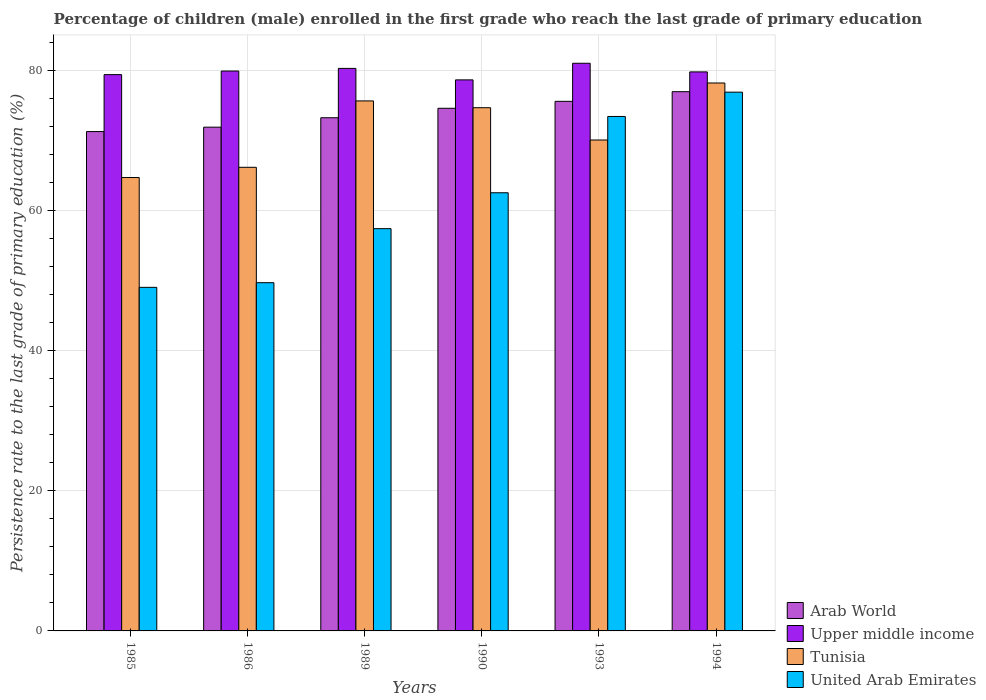How many different coloured bars are there?
Keep it short and to the point. 4. Are the number of bars per tick equal to the number of legend labels?
Make the answer very short. Yes. Are the number of bars on each tick of the X-axis equal?
Give a very brief answer. Yes. How many bars are there on the 5th tick from the left?
Keep it short and to the point. 4. How many bars are there on the 5th tick from the right?
Provide a short and direct response. 4. What is the label of the 4th group of bars from the left?
Ensure brevity in your answer.  1990. In how many cases, is the number of bars for a given year not equal to the number of legend labels?
Give a very brief answer. 0. What is the persistence rate of children in United Arab Emirates in 1994?
Provide a short and direct response. 76.92. Across all years, what is the maximum persistence rate of children in Upper middle income?
Offer a terse response. 81.05. Across all years, what is the minimum persistence rate of children in Arab World?
Your answer should be compact. 71.3. In which year was the persistence rate of children in Tunisia maximum?
Make the answer very short. 1994. In which year was the persistence rate of children in United Arab Emirates minimum?
Make the answer very short. 1985. What is the total persistence rate of children in United Arab Emirates in the graph?
Your answer should be compact. 369.13. What is the difference between the persistence rate of children in Upper middle income in 1993 and that in 1994?
Offer a very short reply. 1.23. What is the difference between the persistence rate of children in United Arab Emirates in 1989 and the persistence rate of children in Arab World in 1990?
Offer a terse response. -17.19. What is the average persistence rate of children in Tunisia per year?
Your answer should be compact. 71.6. In the year 1994, what is the difference between the persistence rate of children in Upper middle income and persistence rate of children in United Arab Emirates?
Your response must be concise. 2.89. What is the ratio of the persistence rate of children in United Arab Emirates in 1986 to that in 1989?
Provide a succinct answer. 0.87. What is the difference between the highest and the second highest persistence rate of children in Upper middle income?
Make the answer very short. 0.73. What is the difference between the highest and the lowest persistence rate of children in Upper middle income?
Offer a terse response. 2.37. In how many years, is the persistence rate of children in Upper middle income greater than the average persistence rate of children in Upper middle income taken over all years?
Ensure brevity in your answer.  3. What does the 4th bar from the left in 1989 represents?
Your response must be concise. United Arab Emirates. What does the 2nd bar from the right in 1993 represents?
Your response must be concise. Tunisia. Is it the case that in every year, the sum of the persistence rate of children in United Arab Emirates and persistence rate of children in Tunisia is greater than the persistence rate of children in Upper middle income?
Offer a very short reply. Yes. Are all the bars in the graph horizontal?
Make the answer very short. No. Does the graph contain grids?
Keep it short and to the point. Yes. Where does the legend appear in the graph?
Your answer should be very brief. Bottom right. How many legend labels are there?
Offer a very short reply. 4. What is the title of the graph?
Give a very brief answer. Percentage of children (male) enrolled in the first grade who reach the last grade of primary education. What is the label or title of the Y-axis?
Provide a succinct answer. Persistence rate to the last grade of primary education (%). What is the Persistence rate to the last grade of primary education (%) in Arab World in 1985?
Your answer should be very brief. 71.3. What is the Persistence rate to the last grade of primary education (%) in Upper middle income in 1985?
Make the answer very short. 79.43. What is the Persistence rate to the last grade of primary education (%) in Tunisia in 1985?
Provide a short and direct response. 64.73. What is the Persistence rate to the last grade of primary education (%) in United Arab Emirates in 1985?
Offer a very short reply. 49.05. What is the Persistence rate to the last grade of primary education (%) in Arab World in 1986?
Your answer should be compact. 71.92. What is the Persistence rate to the last grade of primary education (%) of Upper middle income in 1986?
Provide a succinct answer. 79.94. What is the Persistence rate to the last grade of primary education (%) of Tunisia in 1986?
Provide a short and direct response. 66.19. What is the Persistence rate to the last grade of primary education (%) in United Arab Emirates in 1986?
Give a very brief answer. 49.72. What is the Persistence rate to the last grade of primary education (%) in Arab World in 1989?
Provide a short and direct response. 73.27. What is the Persistence rate to the last grade of primary education (%) in Upper middle income in 1989?
Provide a short and direct response. 80.31. What is the Persistence rate to the last grade of primary education (%) in Tunisia in 1989?
Make the answer very short. 75.67. What is the Persistence rate to the last grade of primary education (%) of United Arab Emirates in 1989?
Offer a terse response. 57.43. What is the Persistence rate to the last grade of primary education (%) of Arab World in 1990?
Your answer should be very brief. 74.62. What is the Persistence rate to the last grade of primary education (%) of Upper middle income in 1990?
Provide a succinct answer. 78.67. What is the Persistence rate to the last grade of primary education (%) of Tunisia in 1990?
Provide a succinct answer. 74.7. What is the Persistence rate to the last grade of primary education (%) in United Arab Emirates in 1990?
Provide a succinct answer. 62.56. What is the Persistence rate to the last grade of primary education (%) in Arab World in 1993?
Make the answer very short. 75.61. What is the Persistence rate to the last grade of primary education (%) of Upper middle income in 1993?
Your answer should be compact. 81.05. What is the Persistence rate to the last grade of primary education (%) in Tunisia in 1993?
Keep it short and to the point. 70.09. What is the Persistence rate to the last grade of primary education (%) in United Arab Emirates in 1993?
Your answer should be compact. 73.45. What is the Persistence rate to the last grade of primary education (%) of Arab World in 1994?
Give a very brief answer. 76.99. What is the Persistence rate to the last grade of primary education (%) in Upper middle income in 1994?
Your answer should be very brief. 79.81. What is the Persistence rate to the last grade of primary education (%) of Tunisia in 1994?
Your answer should be very brief. 78.23. What is the Persistence rate to the last grade of primary education (%) in United Arab Emirates in 1994?
Your response must be concise. 76.92. Across all years, what is the maximum Persistence rate to the last grade of primary education (%) of Arab World?
Ensure brevity in your answer.  76.99. Across all years, what is the maximum Persistence rate to the last grade of primary education (%) in Upper middle income?
Make the answer very short. 81.05. Across all years, what is the maximum Persistence rate to the last grade of primary education (%) of Tunisia?
Keep it short and to the point. 78.23. Across all years, what is the maximum Persistence rate to the last grade of primary education (%) in United Arab Emirates?
Your answer should be very brief. 76.92. Across all years, what is the minimum Persistence rate to the last grade of primary education (%) of Arab World?
Provide a succinct answer. 71.3. Across all years, what is the minimum Persistence rate to the last grade of primary education (%) in Upper middle income?
Offer a terse response. 78.67. Across all years, what is the minimum Persistence rate to the last grade of primary education (%) of Tunisia?
Ensure brevity in your answer.  64.73. Across all years, what is the minimum Persistence rate to the last grade of primary education (%) in United Arab Emirates?
Offer a very short reply. 49.05. What is the total Persistence rate to the last grade of primary education (%) in Arab World in the graph?
Your answer should be very brief. 443.71. What is the total Persistence rate to the last grade of primary education (%) in Upper middle income in the graph?
Keep it short and to the point. 479.21. What is the total Persistence rate to the last grade of primary education (%) in Tunisia in the graph?
Make the answer very short. 429.62. What is the total Persistence rate to the last grade of primary education (%) in United Arab Emirates in the graph?
Provide a succinct answer. 369.13. What is the difference between the Persistence rate to the last grade of primary education (%) in Arab World in 1985 and that in 1986?
Ensure brevity in your answer.  -0.63. What is the difference between the Persistence rate to the last grade of primary education (%) in Upper middle income in 1985 and that in 1986?
Your response must be concise. -0.51. What is the difference between the Persistence rate to the last grade of primary education (%) of Tunisia in 1985 and that in 1986?
Offer a very short reply. -1.46. What is the difference between the Persistence rate to the last grade of primary education (%) of United Arab Emirates in 1985 and that in 1986?
Your response must be concise. -0.66. What is the difference between the Persistence rate to the last grade of primary education (%) in Arab World in 1985 and that in 1989?
Offer a terse response. -1.97. What is the difference between the Persistence rate to the last grade of primary education (%) of Upper middle income in 1985 and that in 1989?
Make the answer very short. -0.89. What is the difference between the Persistence rate to the last grade of primary education (%) of Tunisia in 1985 and that in 1989?
Offer a terse response. -10.94. What is the difference between the Persistence rate to the last grade of primary education (%) of United Arab Emirates in 1985 and that in 1989?
Ensure brevity in your answer.  -8.38. What is the difference between the Persistence rate to the last grade of primary education (%) of Arab World in 1985 and that in 1990?
Provide a succinct answer. -3.32. What is the difference between the Persistence rate to the last grade of primary education (%) of Upper middle income in 1985 and that in 1990?
Keep it short and to the point. 0.75. What is the difference between the Persistence rate to the last grade of primary education (%) in Tunisia in 1985 and that in 1990?
Ensure brevity in your answer.  -9.97. What is the difference between the Persistence rate to the last grade of primary education (%) of United Arab Emirates in 1985 and that in 1990?
Your response must be concise. -13.5. What is the difference between the Persistence rate to the last grade of primary education (%) in Arab World in 1985 and that in 1993?
Offer a very short reply. -4.32. What is the difference between the Persistence rate to the last grade of primary education (%) in Upper middle income in 1985 and that in 1993?
Ensure brevity in your answer.  -1.62. What is the difference between the Persistence rate to the last grade of primary education (%) of Tunisia in 1985 and that in 1993?
Your response must be concise. -5.36. What is the difference between the Persistence rate to the last grade of primary education (%) in United Arab Emirates in 1985 and that in 1993?
Provide a succinct answer. -24.4. What is the difference between the Persistence rate to the last grade of primary education (%) in Arab World in 1985 and that in 1994?
Provide a short and direct response. -5.69. What is the difference between the Persistence rate to the last grade of primary education (%) in Upper middle income in 1985 and that in 1994?
Ensure brevity in your answer.  -0.39. What is the difference between the Persistence rate to the last grade of primary education (%) of Tunisia in 1985 and that in 1994?
Your answer should be compact. -13.5. What is the difference between the Persistence rate to the last grade of primary education (%) in United Arab Emirates in 1985 and that in 1994?
Your response must be concise. -27.87. What is the difference between the Persistence rate to the last grade of primary education (%) in Arab World in 1986 and that in 1989?
Offer a very short reply. -1.35. What is the difference between the Persistence rate to the last grade of primary education (%) of Upper middle income in 1986 and that in 1989?
Make the answer very short. -0.37. What is the difference between the Persistence rate to the last grade of primary education (%) of Tunisia in 1986 and that in 1989?
Your answer should be very brief. -9.48. What is the difference between the Persistence rate to the last grade of primary education (%) of United Arab Emirates in 1986 and that in 1989?
Provide a short and direct response. -7.71. What is the difference between the Persistence rate to the last grade of primary education (%) of Arab World in 1986 and that in 1990?
Offer a very short reply. -2.7. What is the difference between the Persistence rate to the last grade of primary education (%) in Upper middle income in 1986 and that in 1990?
Provide a short and direct response. 1.27. What is the difference between the Persistence rate to the last grade of primary education (%) in Tunisia in 1986 and that in 1990?
Provide a short and direct response. -8.51. What is the difference between the Persistence rate to the last grade of primary education (%) of United Arab Emirates in 1986 and that in 1990?
Your answer should be very brief. -12.84. What is the difference between the Persistence rate to the last grade of primary education (%) of Arab World in 1986 and that in 1993?
Your answer should be very brief. -3.69. What is the difference between the Persistence rate to the last grade of primary education (%) of Upper middle income in 1986 and that in 1993?
Offer a terse response. -1.11. What is the difference between the Persistence rate to the last grade of primary education (%) in Tunisia in 1986 and that in 1993?
Your response must be concise. -3.9. What is the difference between the Persistence rate to the last grade of primary education (%) in United Arab Emirates in 1986 and that in 1993?
Make the answer very short. -23.73. What is the difference between the Persistence rate to the last grade of primary education (%) of Arab World in 1986 and that in 1994?
Keep it short and to the point. -5.07. What is the difference between the Persistence rate to the last grade of primary education (%) in Upper middle income in 1986 and that in 1994?
Offer a very short reply. 0.13. What is the difference between the Persistence rate to the last grade of primary education (%) in Tunisia in 1986 and that in 1994?
Ensure brevity in your answer.  -12.04. What is the difference between the Persistence rate to the last grade of primary education (%) of United Arab Emirates in 1986 and that in 1994?
Give a very brief answer. -27.2. What is the difference between the Persistence rate to the last grade of primary education (%) of Arab World in 1989 and that in 1990?
Provide a short and direct response. -1.35. What is the difference between the Persistence rate to the last grade of primary education (%) in Upper middle income in 1989 and that in 1990?
Provide a succinct answer. 1.64. What is the difference between the Persistence rate to the last grade of primary education (%) of Tunisia in 1989 and that in 1990?
Your answer should be very brief. 0.97. What is the difference between the Persistence rate to the last grade of primary education (%) in United Arab Emirates in 1989 and that in 1990?
Your response must be concise. -5.13. What is the difference between the Persistence rate to the last grade of primary education (%) in Arab World in 1989 and that in 1993?
Keep it short and to the point. -2.34. What is the difference between the Persistence rate to the last grade of primary education (%) of Upper middle income in 1989 and that in 1993?
Ensure brevity in your answer.  -0.73. What is the difference between the Persistence rate to the last grade of primary education (%) in Tunisia in 1989 and that in 1993?
Make the answer very short. 5.58. What is the difference between the Persistence rate to the last grade of primary education (%) in United Arab Emirates in 1989 and that in 1993?
Provide a succinct answer. -16.02. What is the difference between the Persistence rate to the last grade of primary education (%) in Arab World in 1989 and that in 1994?
Keep it short and to the point. -3.72. What is the difference between the Persistence rate to the last grade of primary education (%) in Upper middle income in 1989 and that in 1994?
Your response must be concise. 0.5. What is the difference between the Persistence rate to the last grade of primary education (%) in Tunisia in 1989 and that in 1994?
Make the answer very short. -2.56. What is the difference between the Persistence rate to the last grade of primary education (%) in United Arab Emirates in 1989 and that in 1994?
Offer a very short reply. -19.49. What is the difference between the Persistence rate to the last grade of primary education (%) in Arab World in 1990 and that in 1993?
Provide a succinct answer. -0.99. What is the difference between the Persistence rate to the last grade of primary education (%) in Upper middle income in 1990 and that in 1993?
Your response must be concise. -2.37. What is the difference between the Persistence rate to the last grade of primary education (%) in Tunisia in 1990 and that in 1993?
Give a very brief answer. 4.61. What is the difference between the Persistence rate to the last grade of primary education (%) of United Arab Emirates in 1990 and that in 1993?
Your response must be concise. -10.89. What is the difference between the Persistence rate to the last grade of primary education (%) in Arab World in 1990 and that in 1994?
Offer a very short reply. -2.37. What is the difference between the Persistence rate to the last grade of primary education (%) of Upper middle income in 1990 and that in 1994?
Keep it short and to the point. -1.14. What is the difference between the Persistence rate to the last grade of primary education (%) in Tunisia in 1990 and that in 1994?
Provide a succinct answer. -3.53. What is the difference between the Persistence rate to the last grade of primary education (%) of United Arab Emirates in 1990 and that in 1994?
Ensure brevity in your answer.  -14.36. What is the difference between the Persistence rate to the last grade of primary education (%) in Arab World in 1993 and that in 1994?
Make the answer very short. -1.38. What is the difference between the Persistence rate to the last grade of primary education (%) in Upper middle income in 1993 and that in 1994?
Provide a succinct answer. 1.23. What is the difference between the Persistence rate to the last grade of primary education (%) in Tunisia in 1993 and that in 1994?
Offer a very short reply. -8.14. What is the difference between the Persistence rate to the last grade of primary education (%) of United Arab Emirates in 1993 and that in 1994?
Offer a very short reply. -3.47. What is the difference between the Persistence rate to the last grade of primary education (%) in Arab World in 1985 and the Persistence rate to the last grade of primary education (%) in Upper middle income in 1986?
Provide a short and direct response. -8.64. What is the difference between the Persistence rate to the last grade of primary education (%) in Arab World in 1985 and the Persistence rate to the last grade of primary education (%) in Tunisia in 1986?
Your response must be concise. 5.1. What is the difference between the Persistence rate to the last grade of primary education (%) in Arab World in 1985 and the Persistence rate to the last grade of primary education (%) in United Arab Emirates in 1986?
Offer a terse response. 21.58. What is the difference between the Persistence rate to the last grade of primary education (%) of Upper middle income in 1985 and the Persistence rate to the last grade of primary education (%) of Tunisia in 1986?
Give a very brief answer. 13.23. What is the difference between the Persistence rate to the last grade of primary education (%) in Upper middle income in 1985 and the Persistence rate to the last grade of primary education (%) in United Arab Emirates in 1986?
Provide a succinct answer. 29.71. What is the difference between the Persistence rate to the last grade of primary education (%) in Tunisia in 1985 and the Persistence rate to the last grade of primary education (%) in United Arab Emirates in 1986?
Ensure brevity in your answer.  15.01. What is the difference between the Persistence rate to the last grade of primary education (%) of Arab World in 1985 and the Persistence rate to the last grade of primary education (%) of Upper middle income in 1989?
Keep it short and to the point. -9.02. What is the difference between the Persistence rate to the last grade of primary education (%) of Arab World in 1985 and the Persistence rate to the last grade of primary education (%) of Tunisia in 1989?
Keep it short and to the point. -4.38. What is the difference between the Persistence rate to the last grade of primary education (%) of Arab World in 1985 and the Persistence rate to the last grade of primary education (%) of United Arab Emirates in 1989?
Your answer should be very brief. 13.86. What is the difference between the Persistence rate to the last grade of primary education (%) of Upper middle income in 1985 and the Persistence rate to the last grade of primary education (%) of Tunisia in 1989?
Provide a succinct answer. 3.75. What is the difference between the Persistence rate to the last grade of primary education (%) of Upper middle income in 1985 and the Persistence rate to the last grade of primary education (%) of United Arab Emirates in 1989?
Offer a terse response. 21.99. What is the difference between the Persistence rate to the last grade of primary education (%) of Tunisia in 1985 and the Persistence rate to the last grade of primary education (%) of United Arab Emirates in 1989?
Keep it short and to the point. 7.3. What is the difference between the Persistence rate to the last grade of primary education (%) of Arab World in 1985 and the Persistence rate to the last grade of primary education (%) of Upper middle income in 1990?
Your answer should be compact. -7.38. What is the difference between the Persistence rate to the last grade of primary education (%) in Arab World in 1985 and the Persistence rate to the last grade of primary education (%) in Tunisia in 1990?
Keep it short and to the point. -3.41. What is the difference between the Persistence rate to the last grade of primary education (%) of Arab World in 1985 and the Persistence rate to the last grade of primary education (%) of United Arab Emirates in 1990?
Your answer should be compact. 8.74. What is the difference between the Persistence rate to the last grade of primary education (%) in Upper middle income in 1985 and the Persistence rate to the last grade of primary education (%) in Tunisia in 1990?
Give a very brief answer. 4.72. What is the difference between the Persistence rate to the last grade of primary education (%) of Upper middle income in 1985 and the Persistence rate to the last grade of primary education (%) of United Arab Emirates in 1990?
Provide a succinct answer. 16.87. What is the difference between the Persistence rate to the last grade of primary education (%) of Tunisia in 1985 and the Persistence rate to the last grade of primary education (%) of United Arab Emirates in 1990?
Your answer should be compact. 2.17. What is the difference between the Persistence rate to the last grade of primary education (%) of Arab World in 1985 and the Persistence rate to the last grade of primary education (%) of Upper middle income in 1993?
Provide a short and direct response. -9.75. What is the difference between the Persistence rate to the last grade of primary education (%) in Arab World in 1985 and the Persistence rate to the last grade of primary education (%) in Tunisia in 1993?
Make the answer very short. 1.21. What is the difference between the Persistence rate to the last grade of primary education (%) of Arab World in 1985 and the Persistence rate to the last grade of primary education (%) of United Arab Emirates in 1993?
Your answer should be very brief. -2.16. What is the difference between the Persistence rate to the last grade of primary education (%) of Upper middle income in 1985 and the Persistence rate to the last grade of primary education (%) of Tunisia in 1993?
Make the answer very short. 9.34. What is the difference between the Persistence rate to the last grade of primary education (%) of Upper middle income in 1985 and the Persistence rate to the last grade of primary education (%) of United Arab Emirates in 1993?
Your answer should be compact. 5.97. What is the difference between the Persistence rate to the last grade of primary education (%) of Tunisia in 1985 and the Persistence rate to the last grade of primary education (%) of United Arab Emirates in 1993?
Your answer should be very brief. -8.72. What is the difference between the Persistence rate to the last grade of primary education (%) in Arab World in 1985 and the Persistence rate to the last grade of primary education (%) in Upper middle income in 1994?
Provide a succinct answer. -8.52. What is the difference between the Persistence rate to the last grade of primary education (%) of Arab World in 1985 and the Persistence rate to the last grade of primary education (%) of Tunisia in 1994?
Make the answer very short. -6.93. What is the difference between the Persistence rate to the last grade of primary education (%) in Arab World in 1985 and the Persistence rate to the last grade of primary education (%) in United Arab Emirates in 1994?
Provide a succinct answer. -5.62. What is the difference between the Persistence rate to the last grade of primary education (%) of Upper middle income in 1985 and the Persistence rate to the last grade of primary education (%) of Tunisia in 1994?
Your answer should be compact. 1.2. What is the difference between the Persistence rate to the last grade of primary education (%) in Upper middle income in 1985 and the Persistence rate to the last grade of primary education (%) in United Arab Emirates in 1994?
Your answer should be compact. 2.5. What is the difference between the Persistence rate to the last grade of primary education (%) of Tunisia in 1985 and the Persistence rate to the last grade of primary education (%) of United Arab Emirates in 1994?
Provide a succinct answer. -12.19. What is the difference between the Persistence rate to the last grade of primary education (%) in Arab World in 1986 and the Persistence rate to the last grade of primary education (%) in Upper middle income in 1989?
Give a very brief answer. -8.39. What is the difference between the Persistence rate to the last grade of primary education (%) of Arab World in 1986 and the Persistence rate to the last grade of primary education (%) of Tunisia in 1989?
Your response must be concise. -3.75. What is the difference between the Persistence rate to the last grade of primary education (%) in Arab World in 1986 and the Persistence rate to the last grade of primary education (%) in United Arab Emirates in 1989?
Offer a terse response. 14.49. What is the difference between the Persistence rate to the last grade of primary education (%) of Upper middle income in 1986 and the Persistence rate to the last grade of primary education (%) of Tunisia in 1989?
Provide a succinct answer. 4.27. What is the difference between the Persistence rate to the last grade of primary education (%) of Upper middle income in 1986 and the Persistence rate to the last grade of primary education (%) of United Arab Emirates in 1989?
Provide a succinct answer. 22.51. What is the difference between the Persistence rate to the last grade of primary education (%) of Tunisia in 1986 and the Persistence rate to the last grade of primary education (%) of United Arab Emirates in 1989?
Keep it short and to the point. 8.76. What is the difference between the Persistence rate to the last grade of primary education (%) in Arab World in 1986 and the Persistence rate to the last grade of primary education (%) in Upper middle income in 1990?
Provide a short and direct response. -6.75. What is the difference between the Persistence rate to the last grade of primary education (%) of Arab World in 1986 and the Persistence rate to the last grade of primary education (%) of Tunisia in 1990?
Offer a very short reply. -2.78. What is the difference between the Persistence rate to the last grade of primary education (%) of Arab World in 1986 and the Persistence rate to the last grade of primary education (%) of United Arab Emirates in 1990?
Your answer should be very brief. 9.37. What is the difference between the Persistence rate to the last grade of primary education (%) in Upper middle income in 1986 and the Persistence rate to the last grade of primary education (%) in Tunisia in 1990?
Offer a terse response. 5.24. What is the difference between the Persistence rate to the last grade of primary education (%) of Upper middle income in 1986 and the Persistence rate to the last grade of primary education (%) of United Arab Emirates in 1990?
Your answer should be very brief. 17.38. What is the difference between the Persistence rate to the last grade of primary education (%) of Tunisia in 1986 and the Persistence rate to the last grade of primary education (%) of United Arab Emirates in 1990?
Offer a terse response. 3.63. What is the difference between the Persistence rate to the last grade of primary education (%) in Arab World in 1986 and the Persistence rate to the last grade of primary education (%) in Upper middle income in 1993?
Your answer should be very brief. -9.12. What is the difference between the Persistence rate to the last grade of primary education (%) in Arab World in 1986 and the Persistence rate to the last grade of primary education (%) in Tunisia in 1993?
Provide a succinct answer. 1.83. What is the difference between the Persistence rate to the last grade of primary education (%) of Arab World in 1986 and the Persistence rate to the last grade of primary education (%) of United Arab Emirates in 1993?
Provide a succinct answer. -1.53. What is the difference between the Persistence rate to the last grade of primary education (%) of Upper middle income in 1986 and the Persistence rate to the last grade of primary education (%) of Tunisia in 1993?
Make the answer very short. 9.85. What is the difference between the Persistence rate to the last grade of primary education (%) of Upper middle income in 1986 and the Persistence rate to the last grade of primary education (%) of United Arab Emirates in 1993?
Your answer should be very brief. 6.49. What is the difference between the Persistence rate to the last grade of primary education (%) of Tunisia in 1986 and the Persistence rate to the last grade of primary education (%) of United Arab Emirates in 1993?
Ensure brevity in your answer.  -7.26. What is the difference between the Persistence rate to the last grade of primary education (%) of Arab World in 1986 and the Persistence rate to the last grade of primary education (%) of Upper middle income in 1994?
Make the answer very short. -7.89. What is the difference between the Persistence rate to the last grade of primary education (%) in Arab World in 1986 and the Persistence rate to the last grade of primary education (%) in Tunisia in 1994?
Make the answer very short. -6.31. What is the difference between the Persistence rate to the last grade of primary education (%) of Arab World in 1986 and the Persistence rate to the last grade of primary education (%) of United Arab Emirates in 1994?
Ensure brevity in your answer.  -5. What is the difference between the Persistence rate to the last grade of primary education (%) of Upper middle income in 1986 and the Persistence rate to the last grade of primary education (%) of Tunisia in 1994?
Make the answer very short. 1.71. What is the difference between the Persistence rate to the last grade of primary education (%) of Upper middle income in 1986 and the Persistence rate to the last grade of primary education (%) of United Arab Emirates in 1994?
Your answer should be very brief. 3.02. What is the difference between the Persistence rate to the last grade of primary education (%) of Tunisia in 1986 and the Persistence rate to the last grade of primary education (%) of United Arab Emirates in 1994?
Offer a very short reply. -10.73. What is the difference between the Persistence rate to the last grade of primary education (%) of Arab World in 1989 and the Persistence rate to the last grade of primary education (%) of Upper middle income in 1990?
Provide a succinct answer. -5.4. What is the difference between the Persistence rate to the last grade of primary education (%) of Arab World in 1989 and the Persistence rate to the last grade of primary education (%) of Tunisia in 1990?
Your response must be concise. -1.43. What is the difference between the Persistence rate to the last grade of primary education (%) of Arab World in 1989 and the Persistence rate to the last grade of primary education (%) of United Arab Emirates in 1990?
Your answer should be very brief. 10.71. What is the difference between the Persistence rate to the last grade of primary education (%) in Upper middle income in 1989 and the Persistence rate to the last grade of primary education (%) in Tunisia in 1990?
Make the answer very short. 5.61. What is the difference between the Persistence rate to the last grade of primary education (%) of Upper middle income in 1989 and the Persistence rate to the last grade of primary education (%) of United Arab Emirates in 1990?
Your answer should be very brief. 17.76. What is the difference between the Persistence rate to the last grade of primary education (%) in Tunisia in 1989 and the Persistence rate to the last grade of primary education (%) in United Arab Emirates in 1990?
Your answer should be very brief. 13.11. What is the difference between the Persistence rate to the last grade of primary education (%) of Arab World in 1989 and the Persistence rate to the last grade of primary education (%) of Upper middle income in 1993?
Make the answer very short. -7.78. What is the difference between the Persistence rate to the last grade of primary education (%) of Arab World in 1989 and the Persistence rate to the last grade of primary education (%) of Tunisia in 1993?
Your response must be concise. 3.18. What is the difference between the Persistence rate to the last grade of primary education (%) in Arab World in 1989 and the Persistence rate to the last grade of primary education (%) in United Arab Emirates in 1993?
Offer a terse response. -0.18. What is the difference between the Persistence rate to the last grade of primary education (%) of Upper middle income in 1989 and the Persistence rate to the last grade of primary education (%) of Tunisia in 1993?
Your answer should be very brief. 10.22. What is the difference between the Persistence rate to the last grade of primary education (%) of Upper middle income in 1989 and the Persistence rate to the last grade of primary education (%) of United Arab Emirates in 1993?
Your answer should be very brief. 6.86. What is the difference between the Persistence rate to the last grade of primary education (%) of Tunisia in 1989 and the Persistence rate to the last grade of primary education (%) of United Arab Emirates in 1993?
Make the answer very short. 2.22. What is the difference between the Persistence rate to the last grade of primary education (%) in Arab World in 1989 and the Persistence rate to the last grade of primary education (%) in Upper middle income in 1994?
Give a very brief answer. -6.54. What is the difference between the Persistence rate to the last grade of primary education (%) in Arab World in 1989 and the Persistence rate to the last grade of primary education (%) in Tunisia in 1994?
Offer a very short reply. -4.96. What is the difference between the Persistence rate to the last grade of primary education (%) in Arab World in 1989 and the Persistence rate to the last grade of primary education (%) in United Arab Emirates in 1994?
Make the answer very short. -3.65. What is the difference between the Persistence rate to the last grade of primary education (%) of Upper middle income in 1989 and the Persistence rate to the last grade of primary education (%) of Tunisia in 1994?
Ensure brevity in your answer.  2.08. What is the difference between the Persistence rate to the last grade of primary education (%) in Upper middle income in 1989 and the Persistence rate to the last grade of primary education (%) in United Arab Emirates in 1994?
Offer a terse response. 3.39. What is the difference between the Persistence rate to the last grade of primary education (%) in Tunisia in 1989 and the Persistence rate to the last grade of primary education (%) in United Arab Emirates in 1994?
Your answer should be compact. -1.25. What is the difference between the Persistence rate to the last grade of primary education (%) in Arab World in 1990 and the Persistence rate to the last grade of primary education (%) in Upper middle income in 1993?
Ensure brevity in your answer.  -6.43. What is the difference between the Persistence rate to the last grade of primary education (%) of Arab World in 1990 and the Persistence rate to the last grade of primary education (%) of Tunisia in 1993?
Provide a short and direct response. 4.53. What is the difference between the Persistence rate to the last grade of primary education (%) in Arab World in 1990 and the Persistence rate to the last grade of primary education (%) in United Arab Emirates in 1993?
Provide a short and direct response. 1.17. What is the difference between the Persistence rate to the last grade of primary education (%) of Upper middle income in 1990 and the Persistence rate to the last grade of primary education (%) of Tunisia in 1993?
Give a very brief answer. 8.58. What is the difference between the Persistence rate to the last grade of primary education (%) of Upper middle income in 1990 and the Persistence rate to the last grade of primary education (%) of United Arab Emirates in 1993?
Give a very brief answer. 5.22. What is the difference between the Persistence rate to the last grade of primary education (%) in Tunisia in 1990 and the Persistence rate to the last grade of primary education (%) in United Arab Emirates in 1993?
Provide a succinct answer. 1.25. What is the difference between the Persistence rate to the last grade of primary education (%) in Arab World in 1990 and the Persistence rate to the last grade of primary education (%) in Upper middle income in 1994?
Your answer should be very brief. -5.2. What is the difference between the Persistence rate to the last grade of primary education (%) of Arab World in 1990 and the Persistence rate to the last grade of primary education (%) of Tunisia in 1994?
Ensure brevity in your answer.  -3.61. What is the difference between the Persistence rate to the last grade of primary education (%) in Arab World in 1990 and the Persistence rate to the last grade of primary education (%) in United Arab Emirates in 1994?
Provide a short and direct response. -2.3. What is the difference between the Persistence rate to the last grade of primary education (%) of Upper middle income in 1990 and the Persistence rate to the last grade of primary education (%) of Tunisia in 1994?
Provide a short and direct response. 0.44. What is the difference between the Persistence rate to the last grade of primary education (%) in Upper middle income in 1990 and the Persistence rate to the last grade of primary education (%) in United Arab Emirates in 1994?
Provide a succinct answer. 1.75. What is the difference between the Persistence rate to the last grade of primary education (%) of Tunisia in 1990 and the Persistence rate to the last grade of primary education (%) of United Arab Emirates in 1994?
Make the answer very short. -2.22. What is the difference between the Persistence rate to the last grade of primary education (%) of Arab World in 1993 and the Persistence rate to the last grade of primary education (%) of Upper middle income in 1994?
Give a very brief answer. -4.2. What is the difference between the Persistence rate to the last grade of primary education (%) of Arab World in 1993 and the Persistence rate to the last grade of primary education (%) of Tunisia in 1994?
Keep it short and to the point. -2.62. What is the difference between the Persistence rate to the last grade of primary education (%) in Arab World in 1993 and the Persistence rate to the last grade of primary education (%) in United Arab Emirates in 1994?
Offer a very short reply. -1.31. What is the difference between the Persistence rate to the last grade of primary education (%) in Upper middle income in 1993 and the Persistence rate to the last grade of primary education (%) in Tunisia in 1994?
Ensure brevity in your answer.  2.82. What is the difference between the Persistence rate to the last grade of primary education (%) of Upper middle income in 1993 and the Persistence rate to the last grade of primary education (%) of United Arab Emirates in 1994?
Provide a short and direct response. 4.13. What is the difference between the Persistence rate to the last grade of primary education (%) of Tunisia in 1993 and the Persistence rate to the last grade of primary education (%) of United Arab Emirates in 1994?
Ensure brevity in your answer.  -6.83. What is the average Persistence rate to the last grade of primary education (%) of Arab World per year?
Give a very brief answer. 73.95. What is the average Persistence rate to the last grade of primary education (%) of Upper middle income per year?
Your answer should be compact. 79.87. What is the average Persistence rate to the last grade of primary education (%) of Tunisia per year?
Ensure brevity in your answer.  71.6. What is the average Persistence rate to the last grade of primary education (%) of United Arab Emirates per year?
Provide a short and direct response. 61.52. In the year 1985, what is the difference between the Persistence rate to the last grade of primary education (%) of Arab World and Persistence rate to the last grade of primary education (%) of Upper middle income?
Offer a terse response. -8.13. In the year 1985, what is the difference between the Persistence rate to the last grade of primary education (%) of Arab World and Persistence rate to the last grade of primary education (%) of Tunisia?
Your response must be concise. 6.56. In the year 1985, what is the difference between the Persistence rate to the last grade of primary education (%) in Arab World and Persistence rate to the last grade of primary education (%) in United Arab Emirates?
Offer a very short reply. 22.24. In the year 1985, what is the difference between the Persistence rate to the last grade of primary education (%) in Upper middle income and Persistence rate to the last grade of primary education (%) in Tunisia?
Ensure brevity in your answer.  14.69. In the year 1985, what is the difference between the Persistence rate to the last grade of primary education (%) in Upper middle income and Persistence rate to the last grade of primary education (%) in United Arab Emirates?
Make the answer very short. 30.37. In the year 1985, what is the difference between the Persistence rate to the last grade of primary education (%) of Tunisia and Persistence rate to the last grade of primary education (%) of United Arab Emirates?
Offer a terse response. 15.68. In the year 1986, what is the difference between the Persistence rate to the last grade of primary education (%) of Arab World and Persistence rate to the last grade of primary education (%) of Upper middle income?
Offer a very short reply. -8.02. In the year 1986, what is the difference between the Persistence rate to the last grade of primary education (%) of Arab World and Persistence rate to the last grade of primary education (%) of Tunisia?
Provide a short and direct response. 5.73. In the year 1986, what is the difference between the Persistence rate to the last grade of primary education (%) of Arab World and Persistence rate to the last grade of primary education (%) of United Arab Emirates?
Keep it short and to the point. 22.2. In the year 1986, what is the difference between the Persistence rate to the last grade of primary education (%) in Upper middle income and Persistence rate to the last grade of primary education (%) in Tunisia?
Your response must be concise. 13.75. In the year 1986, what is the difference between the Persistence rate to the last grade of primary education (%) in Upper middle income and Persistence rate to the last grade of primary education (%) in United Arab Emirates?
Offer a very short reply. 30.22. In the year 1986, what is the difference between the Persistence rate to the last grade of primary education (%) in Tunisia and Persistence rate to the last grade of primary education (%) in United Arab Emirates?
Your answer should be very brief. 16.47. In the year 1989, what is the difference between the Persistence rate to the last grade of primary education (%) in Arab World and Persistence rate to the last grade of primary education (%) in Upper middle income?
Your answer should be compact. -7.04. In the year 1989, what is the difference between the Persistence rate to the last grade of primary education (%) in Arab World and Persistence rate to the last grade of primary education (%) in Tunisia?
Your answer should be compact. -2.4. In the year 1989, what is the difference between the Persistence rate to the last grade of primary education (%) of Arab World and Persistence rate to the last grade of primary education (%) of United Arab Emirates?
Offer a very short reply. 15.84. In the year 1989, what is the difference between the Persistence rate to the last grade of primary education (%) in Upper middle income and Persistence rate to the last grade of primary education (%) in Tunisia?
Provide a short and direct response. 4.64. In the year 1989, what is the difference between the Persistence rate to the last grade of primary education (%) of Upper middle income and Persistence rate to the last grade of primary education (%) of United Arab Emirates?
Keep it short and to the point. 22.88. In the year 1989, what is the difference between the Persistence rate to the last grade of primary education (%) of Tunisia and Persistence rate to the last grade of primary education (%) of United Arab Emirates?
Keep it short and to the point. 18.24. In the year 1990, what is the difference between the Persistence rate to the last grade of primary education (%) of Arab World and Persistence rate to the last grade of primary education (%) of Upper middle income?
Ensure brevity in your answer.  -4.05. In the year 1990, what is the difference between the Persistence rate to the last grade of primary education (%) of Arab World and Persistence rate to the last grade of primary education (%) of Tunisia?
Your answer should be compact. -0.08. In the year 1990, what is the difference between the Persistence rate to the last grade of primary education (%) of Arab World and Persistence rate to the last grade of primary education (%) of United Arab Emirates?
Make the answer very short. 12.06. In the year 1990, what is the difference between the Persistence rate to the last grade of primary education (%) of Upper middle income and Persistence rate to the last grade of primary education (%) of Tunisia?
Ensure brevity in your answer.  3.97. In the year 1990, what is the difference between the Persistence rate to the last grade of primary education (%) of Upper middle income and Persistence rate to the last grade of primary education (%) of United Arab Emirates?
Your answer should be very brief. 16.12. In the year 1990, what is the difference between the Persistence rate to the last grade of primary education (%) of Tunisia and Persistence rate to the last grade of primary education (%) of United Arab Emirates?
Your answer should be compact. 12.14. In the year 1993, what is the difference between the Persistence rate to the last grade of primary education (%) in Arab World and Persistence rate to the last grade of primary education (%) in Upper middle income?
Your answer should be compact. -5.44. In the year 1993, what is the difference between the Persistence rate to the last grade of primary education (%) in Arab World and Persistence rate to the last grade of primary education (%) in Tunisia?
Your answer should be compact. 5.52. In the year 1993, what is the difference between the Persistence rate to the last grade of primary education (%) in Arab World and Persistence rate to the last grade of primary education (%) in United Arab Emirates?
Offer a very short reply. 2.16. In the year 1993, what is the difference between the Persistence rate to the last grade of primary education (%) in Upper middle income and Persistence rate to the last grade of primary education (%) in Tunisia?
Your answer should be compact. 10.96. In the year 1993, what is the difference between the Persistence rate to the last grade of primary education (%) of Upper middle income and Persistence rate to the last grade of primary education (%) of United Arab Emirates?
Offer a very short reply. 7.6. In the year 1993, what is the difference between the Persistence rate to the last grade of primary education (%) of Tunisia and Persistence rate to the last grade of primary education (%) of United Arab Emirates?
Keep it short and to the point. -3.36. In the year 1994, what is the difference between the Persistence rate to the last grade of primary education (%) of Arab World and Persistence rate to the last grade of primary education (%) of Upper middle income?
Offer a very short reply. -2.82. In the year 1994, what is the difference between the Persistence rate to the last grade of primary education (%) in Arab World and Persistence rate to the last grade of primary education (%) in Tunisia?
Your response must be concise. -1.24. In the year 1994, what is the difference between the Persistence rate to the last grade of primary education (%) in Arab World and Persistence rate to the last grade of primary education (%) in United Arab Emirates?
Provide a short and direct response. 0.07. In the year 1994, what is the difference between the Persistence rate to the last grade of primary education (%) in Upper middle income and Persistence rate to the last grade of primary education (%) in Tunisia?
Offer a very short reply. 1.58. In the year 1994, what is the difference between the Persistence rate to the last grade of primary education (%) of Upper middle income and Persistence rate to the last grade of primary education (%) of United Arab Emirates?
Make the answer very short. 2.89. In the year 1994, what is the difference between the Persistence rate to the last grade of primary education (%) in Tunisia and Persistence rate to the last grade of primary education (%) in United Arab Emirates?
Provide a succinct answer. 1.31. What is the ratio of the Persistence rate to the last grade of primary education (%) in Arab World in 1985 to that in 1986?
Make the answer very short. 0.99. What is the ratio of the Persistence rate to the last grade of primary education (%) in United Arab Emirates in 1985 to that in 1986?
Your answer should be very brief. 0.99. What is the ratio of the Persistence rate to the last grade of primary education (%) in Arab World in 1985 to that in 1989?
Keep it short and to the point. 0.97. What is the ratio of the Persistence rate to the last grade of primary education (%) in Upper middle income in 1985 to that in 1989?
Keep it short and to the point. 0.99. What is the ratio of the Persistence rate to the last grade of primary education (%) in Tunisia in 1985 to that in 1989?
Your answer should be very brief. 0.86. What is the ratio of the Persistence rate to the last grade of primary education (%) of United Arab Emirates in 1985 to that in 1989?
Your response must be concise. 0.85. What is the ratio of the Persistence rate to the last grade of primary education (%) of Arab World in 1985 to that in 1990?
Offer a terse response. 0.96. What is the ratio of the Persistence rate to the last grade of primary education (%) of Upper middle income in 1985 to that in 1990?
Provide a short and direct response. 1.01. What is the ratio of the Persistence rate to the last grade of primary education (%) in Tunisia in 1985 to that in 1990?
Offer a very short reply. 0.87. What is the ratio of the Persistence rate to the last grade of primary education (%) of United Arab Emirates in 1985 to that in 1990?
Ensure brevity in your answer.  0.78. What is the ratio of the Persistence rate to the last grade of primary education (%) of Arab World in 1985 to that in 1993?
Make the answer very short. 0.94. What is the ratio of the Persistence rate to the last grade of primary education (%) in Upper middle income in 1985 to that in 1993?
Give a very brief answer. 0.98. What is the ratio of the Persistence rate to the last grade of primary education (%) in Tunisia in 1985 to that in 1993?
Your response must be concise. 0.92. What is the ratio of the Persistence rate to the last grade of primary education (%) of United Arab Emirates in 1985 to that in 1993?
Provide a short and direct response. 0.67. What is the ratio of the Persistence rate to the last grade of primary education (%) of Arab World in 1985 to that in 1994?
Your response must be concise. 0.93. What is the ratio of the Persistence rate to the last grade of primary education (%) in Tunisia in 1985 to that in 1994?
Keep it short and to the point. 0.83. What is the ratio of the Persistence rate to the last grade of primary education (%) of United Arab Emirates in 1985 to that in 1994?
Keep it short and to the point. 0.64. What is the ratio of the Persistence rate to the last grade of primary education (%) in Arab World in 1986 to that in 1989?
Your answer should be compact. 0.98. What is the ratio of the Persistence rate to the last grade of primary education (%) in Tunisia in 1986 to that in 1989?
Keep it short and to the point. 0.87. What is the ratio of the Persistence rate to the last grade of primary education (%) of United Arab Emirates in 1986 to that in 1989?
Give a very brief answer. 0.87. What is the ratio of the Persistence rate to the last grade of primary education (%) of Arab World in 1986 to that in 1990?
Provide a short and direct response. 0.96. What is the ratio of the Persistence rate to the last grade of primary education (%) in Upper middle income in 1986 to that in 1990?
Your response must be concise. 1.02. What is the ratio of the Persistence rate to the last grade of primary education (%) in Tunisia in 1986 to that in 1990?
Make the answer very short. 0.89. What is the ratio of the Persistence rate to the last grade of primary education (%) in United Arab Emirates in 1986 to that in 1990?
Your answer should be compact. 0.79. What is the ratio of the Persistence rate to the last grade of primary education (%) in Arab World in 1986 to that in 1993?
Your answer should be very brief. 0.95. What is the ratio of the Persistence rate to the last grade of primary education (%) of Upper middle income in 1986 to that in 1993?
Ensure brevity in your answer.  0.99. What is the ratio of the Persistence rate to the last grade of primary education (%) of Tunisia in 1986 to that in 1993?
Give a very brief answer. 0.94. What is the ratio of the Persistence rate to the last grade of primary education (%) in United Arab Emirates in 1986 to that in 1993?
Give a very brief answer. 0.68. What is the ratio of the Persistence rate to the last grade of primary education (%) in Arab World in 1986 to that in 1994?
Give a very brief answer. 0.93. What is the ratio of the Persistence rate to the last grade of primary education (%) of Upper middle income in 1986 to that in 1994?
Your answer should be very brief. 1. What is the ratio of the Persistence rate to the last grade of primary education (%) in Tunisia in 1986 to that in 1994?
Offer a very short reply. 0.85. What is the ratio of the Persistence rate to the last grade of primary education (%) in United Arab Emirates in 1986 to that in 1994?
Your response must be concise. 0.65. What is the ratio of the Persistence rate to the last grade of primary education (%) in Arab World in 1989 to that in 1990?
Ensure brevity in your answer.  0.98. What is the ratio of the Persistence rate to the last grade of primary education (%) of Upper middle income in 1989 to that in 1990?
Your answer should be very brief. 1.02. What is the ratio of the Persistence rate to the last grade of primary education (%) of United Arab Emirates in 1989 to that in 1990?
Give a very brief answer. 0.92. What is the ratio of the Persistence rate to the last grade of primary education (%) of Upper middle income in 1989 to that in 1993?
Provide a succinct answer. 0.99. What is the ratio of the Persistence rate to the last grade of primary education (%) in Tunisia in 1989 to that in 1993?
Offer a very short reply. 1.08. What is the ratio of the Persistence rate to the last grade of primary education (%) of United Arab Emirates in 1989 to that in 1993?
Give a very brief answer. 0.78. What is the ratio of the Persistence rate to the last grade of primary education (%) of Arab World in 1989 to that in 1994?
Give a very brief answer. 0.95. What is the ratio of the Persistence rate to the last grade of primary education (%) in Tunisia in 1989 to that in 1994?
Give a very brief answer. 0.97. What is the ratio of the Persistence rate to the last grade of primary education (%) of United Arab Emirates in 1989 to that in 1994?
Ensure brevity in your answer.  0.75. What is the ratio of the Persistence rate to the last grade of primary education (%) in Arab World in 1990 to that in 1993?
Your answer should be very brief. 0.99. What is the ratio of the Persistence rate to the last grade of primary education (%) in Upper middle income in 1990 to that in 1993?
Provide a short and direct response. 0.97. What is the ratio of the Persistence rate to the last grade of primary education (%) in Tunisia in 1990 to that in 1993?
Give a very brief answer. 1.07. What is the ratio of the Persistence rate to the last grade of primary education (%) in United Arab Emirates in 1990 to that in 1993?
Your answer should be compact. 0.85. What is the ratio of the Persistence rate to the last grade of primary education (%) of Arab World in 1990 to that in 1994?
Provide a succinct answer. 0.97. What is the ratio of the Persistence rate to the last grade of primary education (%) in Upper middle income in 1990 to that in 1994?
Give a very brief answer. 0.99. What is the ratio of the Persistence rate to the last grade of primary education (%) of Tunisia in 1990 to that in 1994?
Your answer should be very brief. 0.95. What is the ratio of the Persistence rate to the last grade of primary education (%) in United Arab Emirates in 1990 to that in 1994?
Offer a terse response. 0.81. What is the ratio of the Persistence rate to the last grade of primary education (%) in Arab World in 1993 to that in 1994?
Your response must be concise. 0.98. What is the ratio of the Persistence rate to the last grade of primary education (%) in Upper middle income in 1993 to that in 1994?
Offer a very short reply. 1.02. What is the ratio of the Persistence rate to the last grade of primary education (%) of Tunisia in 1993 to that in 1994?
Your answer should be compact. 0.9. What is the ratio of the Persistence rate to the last grade of primary education (%) of United Arab Emirates in 1993 to that in 1994?
Your answer should be compact. 0.95. What is the difference between the highest and the second highest Persistence rate to the last grade of primary education (%) in Arab World?
Give a very brief answer. 1.38. What is the difference between the highest and the second highest Persistence rate to the last grade of primary education (%) of Upper middle income?
Offer a very short reply. 0.73. What is the difference between the highest and the second highest Persistence rate to the last grade of primary education (%) of Tunisia?
Your response must be concise. 2.56. What is the difference between the highest and the second highest Persistence rate to the last grade of primary education (%) of United Arab Emirates?
Give a very brief answer. 3.47. What is the difference between the highest and the lowest Persistence rate to the last grade of primary education (%) of Arab World?
Offer a terse response. 5.69. What is the difference between the highest and the lowest Persistence rate to the last grade of primary education (%) of Upper middle income?
Your response must be concise. 2.37. What is the difference between the highest and the lowest Persistence rate to the last grade of primary education (%) of Tunisia?
Your answer should be compact. 13.5. What is the difference between the highest and the lowest Persistence rate to the last grade of primary education (%) in United Arab Emirates?
Offer a very short reply. 27.87. 